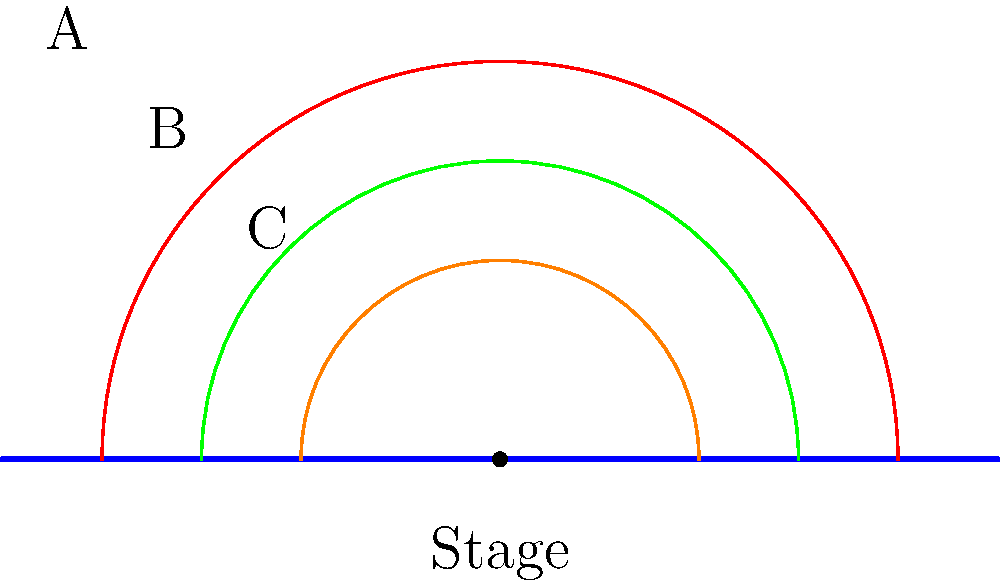As a mentalist magician collaborating on a research project to optimize stage layout, you're tasked with determining the best seating arrangement for maximum visibility. The diagram shows three possible semicircular seating arrangements (A, B, and C) around a central stage point. If the visibility for each audience member is inversely proportional to their distance from the stage, which arrangement maximizes the average visibility for all audience members? Assume a continuous distribution of seats along each arc and use calculus to find the optimal arrangement. Let's approach this step-by-step:

1) First, we need to set up an expression for the average visibility. For a semicircular arrangement with radius $r$, the visibility at any point can be expressed as $\frac{1}{r}$.

2) The average visibility will be the integral of this visibility function over the semicircle, divided by the total arc length:

   $$ \text{Average Visibility} = \frac{\int_0^\pi \frac{1}{r} r d\theta}{\pi r} $$

3) Simplify the integral:
   
   $$ \text{Average Visibility} = \frac{\int_0^\pi d\theta}{\pi r} = \frac{\pi}{\pi r} = \frac{1}{r} $$

4) This result shows that the average visibility is inversely proportional to the radius of the seating arrangement.

5) Looking at the diagram:
   Arrangement A has the largest radius
   Arrangement B has a medium radius
   Arrangement C has the smallest radius

6) Since the average visibility is inversely proportional to the radius, the arrangement with the smallest radius (C) will provide the maximum average visibility.

This result aligns with intuition: having audience members closer to the stage (on average) improves overall visibility.
Answer: Arrangement C 